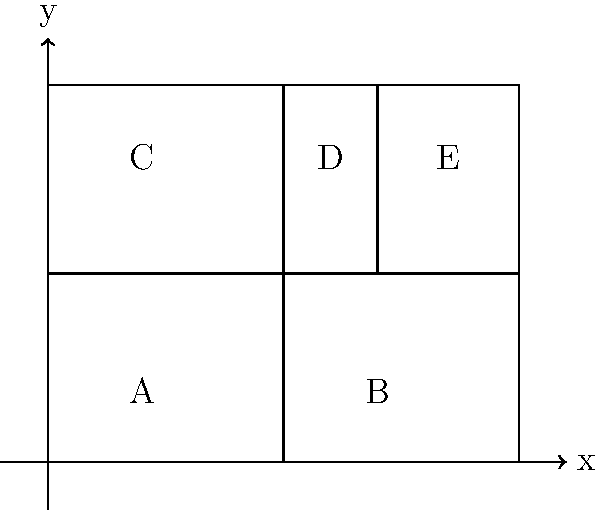In the floor plan of a veteran support center shown above, which pair of lines are parallel to each other? To identify parallel lines, we need to look for lines that maintain a constant distance from each other and never intersect. In this floor plan:

1. The line separating rooms A and C from rooms B, D, and E is vertical and runs from (5,0) to (5,8).
2. The line separating room D from room E is also vertical and runs from (7,4) to (7,8).
3. The line separating rooms A and B from rooms C, D, and E is horizontal and runs from (0,4) to (10,4).

Parallel lines in a coordinate system have the same slope. In this case:

- The vertical lines have undefined slopes (rise/run = ∞) and are parallel to the y-axis.
- The horizontal line has a slope of 0 and is parallel to the x-axis.

The two vertical lines (the one at x=5 and the one at x=7) are parallel to each other because they both have undefined slopes and maintain a constant distance from each other.
Answer: The vertical lines at x=5 and x=7 